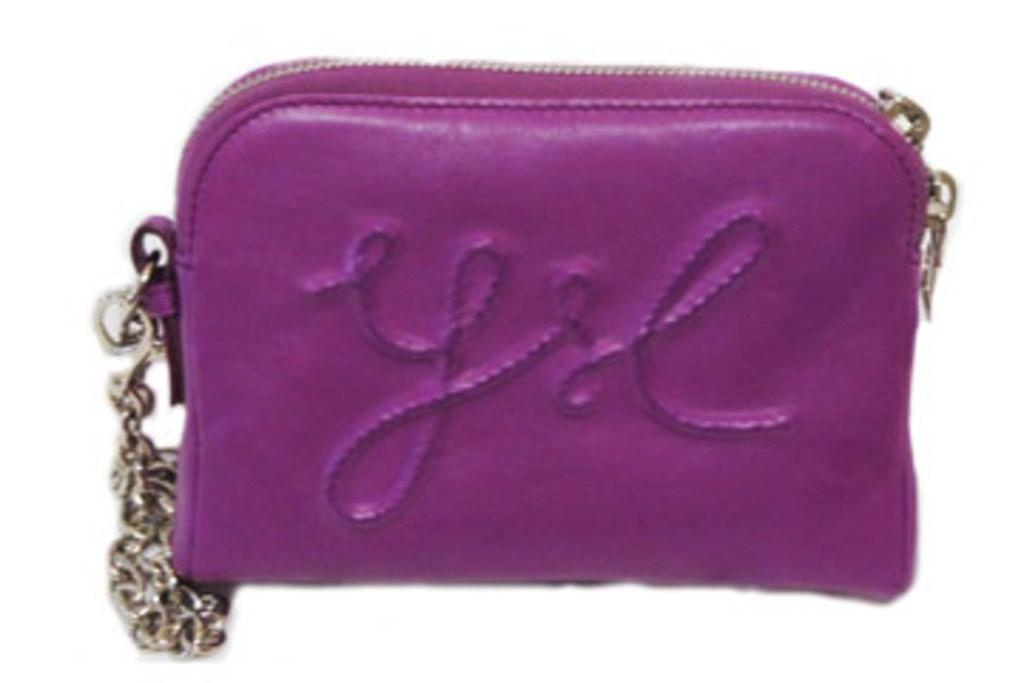What type of accessory is present in the image? There is a handbag in the image. What is attached to the handbag? The handbag has a golden chain. What color is the handbag? The handbag is purple in color. What type of beast can be seen roaming through the sleet in the image? There is no beast or sleet present in the image; it features a handbag with a golden chain and a purple color. 